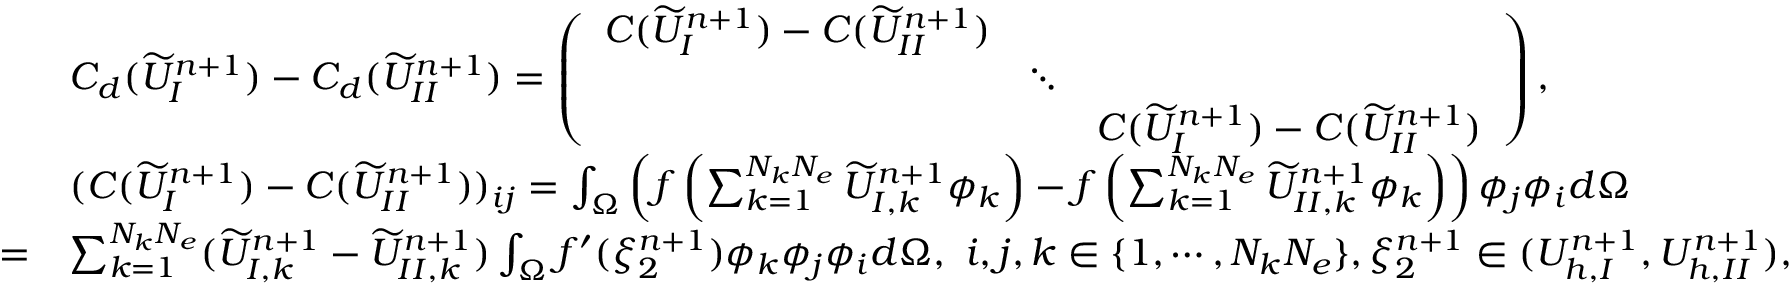<formula> <loc_0><loc_0><loc_500><loc_500>\begin{array} { r l } & { C _ { d } ( \widetilde { U } _ { I } ^ { n + 1 } ) - C _ { d } ( \widetilde { U } _ { I I } ^ { n + 1 } ) = \left ( \begin{array} { c c c } { C ( \widetilde { U } _ { I } ^ { n + 1 } ) - C ( \widetilde { U } _ { I I } ^ { n + 1 } ) } & & \\ & { \ddots } & \\ & & { C ( \widetilde { U } _ { I } ^ { n + 1 } ) - C ( \widetilde { U } _ { I I } ^ { n + 1 } ) } \end{array} \right ) , } \\ & { ( C ( \widetilde { U } _ { I } ^ { n + 1 } ) - C ( \widetilde { U } _ { I I } ^ { n + 1 } ) ) _ { i j } = \int _ { \Omega } \left ( f \left ( \sum _ { k = 1 } ^ { N _ { k } N _ { e } } \widetilde { U } _ { I , k } ^ { n + 1 } \phi _ { k } \right ) - f \left ( \sum _ { k = 1 } ^ { N _ { k } N _ { e } } \widetilde { U } _ { I I , k } ^ { n + 1 } \phi _ { k } \right ) \right ) \phi _ { j } \phi _ { i } d \Omega } \\ { = } & { \sum _ { k = 1 } ^ { N _ { k } N _ { e } } ( \widetilde { U } _ { I , k } ^ { n + 1 } - \widetilde { U } _ { I I , k } ^ { n + 1 } ) \int _ { \Omega } f ^ { \prime } ( \xi _ { 2 } ^ { n + 1 } ) \phi _ { k } \phi _ { j } \phi _ { i } d \Omega , \ i , j , k \in \{ 1 , \cdots , N _ { k } N _ { e } \} , \xi _ { 2 } ^ { n + 1 } \in ( U _ { h , I } ^ { n + 1 } , U _ { h , I I } ^ { n + 1 } ) , } \end{array}</formula> 